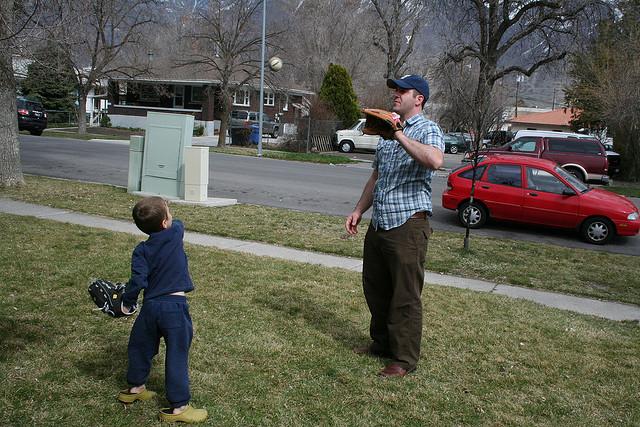What is the person holding up?
Keep it brief. Baseball glove. What is the color of the car?
Be succinct. Red. Why isn't he on a sidewalk?
Concise answer only. Playing. What sport are they playing?
Concise answer only. Baseball. What is the boy trying to do?
Short answer required. Throw ball. What is in the man's hand?
Answer briefly. Glove. How many vehicles can be seen?
Concise answer only. 7. Is the man probably going for a short walk or traveling a long distance?
Give a very brief answer. Short walk. What type of pants is the man wearing?
Keep it brief. Cargo. Is the red car real?
Quick response, please. Yes. What are the boys doing?
Write a very short answer. Playing catch. 